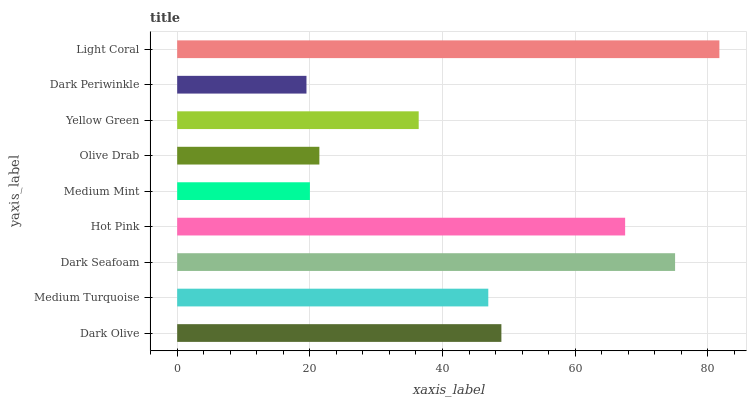Is Dark Periwinkle the minimum?
Answer yes or no. Yes. Is Light Coral the maximum?
Answer yes or no. Yes. Is Medium Turquoise the minimum?
Answer yes or no. No. Is Medium Turquoise the maximum?
Answer yes or no. No. Is Dark Olive greater than Medium Turquoise?
Answer yes or no. Yes. Is Medium Turquoise less than Dark Olive?
Answer yes or no. Yes. Is Medium Turquoise greater than Dark Olive?
Answer yes or no. No. Is Dark Olive less than Medium Turquoise?
Answer yes or no. No. Is Medium Turquoise the high median?
Answer yes or no. Yes. Is Medium Turquoise the low median?
Answer yes or no. Yes. Is Dark Olive the high median?
Answer yes or no. No. Is Olive Drab the low median?
Answer yes or no. No. 